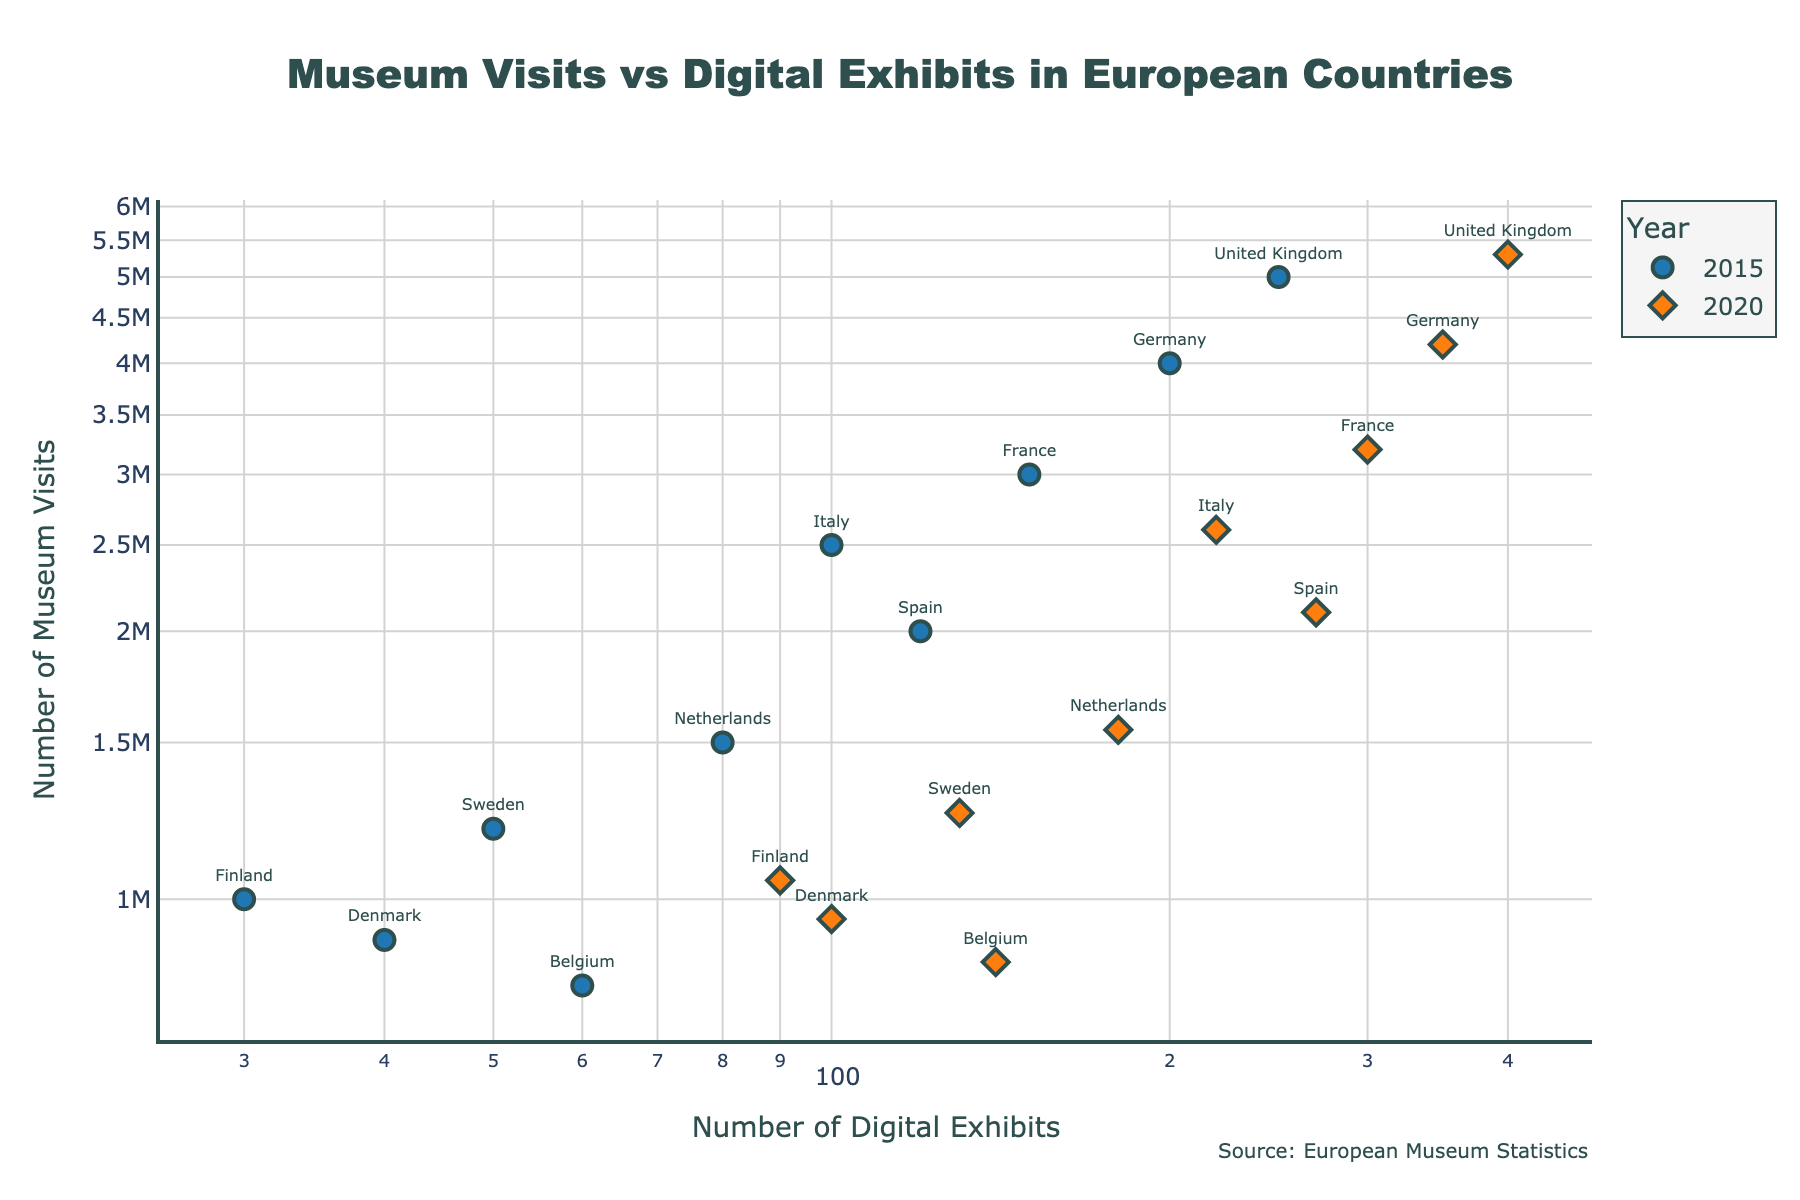What is the title of the scatter plot? The title of the plot is located at the top center of the plot, and it represents the overall subject of the visualization.
Answer: Museum Visits vs Digital Exhibits in European Countries What are the axes titles in the scatter plot? The titles of the axes are displayed alongside each respective axis. The x-axis title describes the horizontal variable, and the y-axis title describes the vertical variable.
Answer: Number of Digital Exhibits (x-axis), Number of Museum Visits (y-axis) Which country had the highest number of museum visits in 2020? To determine this, look for the marker in the 2020 series with the highest y-coordinate value and check its label.
Answer: United Kingdom How did the number of digital exhibits in Germany change from 2015 to 2020? Comparing the x-coordinate values of Germany's markers in the 2015 and 2020 series, notice the difference between the two points on the x-axis.
Answer: Increased from 200 to 350 Which country showed a significant increase in digital exhibits from 2015 to 2020? Identify the country with a substantial horizontal shift from the 2015 to 2020 markers on the x-axis.
Answer: France How does Sweden's number of museum visits in 2020 compare to Belgium's? Check the y-coordinate values of the 2020 markers for both Sweden and Belgium; Belgium is slightly lower than Sweden.
Answer: Sweden had more visits Which two countries had nearly equal numbers of digital exhibits in 2015? Find two countries whose markers are close to each other along the x-axis for the 2015 series.
Answer: Denmark and Belgium Did any country have a decrease in museum visits from 2015 to 2020? Compare the y-coordinate values of 2015 and 2020 markers for each country to see if any y-coordinate decreased in 2020.
Answer: No What's the average number of museum visits in 2020 across all countries? Add the y-coordinate values of the 2020 markers for all countries and divide by the number of countries. (4200000 + 3200000 + 2600000 + 2100000 + 5300000 + 1550000 + 1250000 + 1050000 + 950000 + 850000) / 10 = 2320000
Answer: 2320000 Which country had the least number of digital exhibits in 2015? Locate the marker farthest to the left on the x-axis for the 2015 series and identify its label.
Answer: Finland 